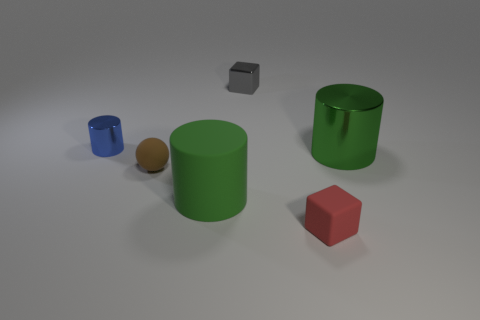Are there any other things that are the same color as the small shiny cylinder?
Your response must be concise. No. What number of balls are purple metal objects or gray things?
Keep it short and to the point. 0. What is the material of the block that is behind the metal cylinder that is in front of the tiny object that is on the left side of the brown rubber object?
Offer a terse response. Metal. There is a big cylinder that is the same color as the large matte object; what is its material?
Your response must be concise. Metal. What number of other tiny red blocks are the same material as the tiny red cube?
Provide a short and direct response. 0. There is a block that is behind the matte cylinder; is it the same size as the tiny red matte cube?
Keep it short and to the point. Yes. There is a block that is the same material as the tiny brown object; what color is it?
Offer a very short reply. Red. There is a big shiny thing; what number of small things are to the right of it?
Keep it short and to the point. 0. Does the big thing that is in front of the brown matte thing have the same color as the cylinder that is to the right of the small gray metallic cube?
Provide a succinct answer. Yes. What is the color of the other large thing that is the same shape as the green rubber object?
Keep it short and to the point. Green. 